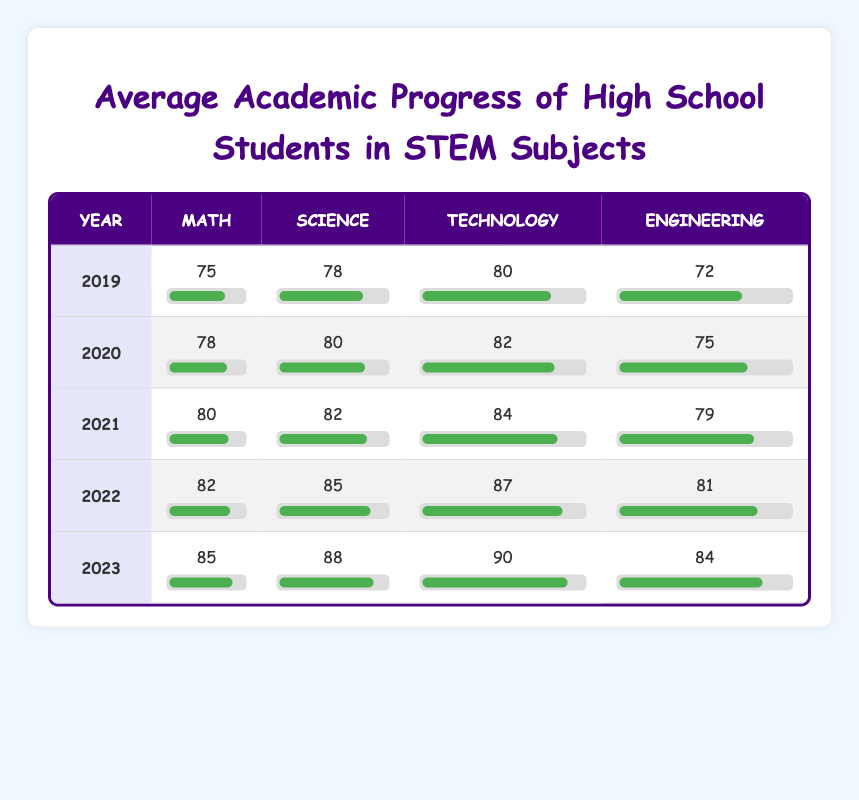What was the average Math score over the five years? To find the average Math score, we add the scores for each year: 75 + 78 + 80 + 82 + 85 = 400. We then divide by the number of years (5), so 400 / 5 = 80.
Answer: 80 Which year had the highest Science score? By looking at the Science column, we see the scores for each year: 78, 80, 82, 85, and 88. The highest score is 88 in 2023.
Answer: 2023 Did the Engineering score improve every year? We compare the Engineering scores year by year: 72, 75, 79, 81, and 84. Since each year shows an increase, we conclude that the Engineering score indeed improved every year.
Answer: Yes What is the difference between the highest and lowest Technology scores in the table? The highest Technology score is 90 in 2023, and the lowest is 80 in 2019. The difference is 90 - 80 = 10.
Answer: 10 In which year did students score an average of 81 across all subjects? To find the year where the average score is 81, we calculate the average for each: for 2019 = (75 + 78 + 80 + 72) / 4 = 76.25; for 2020 = (78 + 80 + 82 + 75) / 4 = 78.75; for 2021 = (80 + 82 + 84 + 79) / 4 = 81.25; for 2022 = (82 + 85 + 87 + 81) / 4 = 83.75; for 2023 = (85 + 88 + 90 + 84) / 4 = 86.25. There is no year with an exact average of 81 across all subjects.
Answer: None What was the overall increase in Math scores from 2019 to 2023? The Math score in 2019 was 75 and in 2023 it was 85. To find the increase, we subtract the earlier score from the later one: 85 - 75 = 10.
Answer: 10 